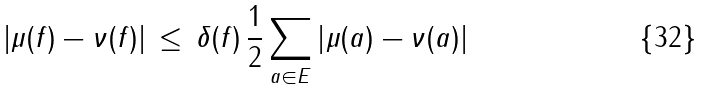<formula> <loc_0><loc_0><loc_500><loc_500>\left | \mu ( f ) - \nu ( f ) \right | \, \leq \, \delta ( f ) \, \frac { 1 } { 2 } \sum _ { a \in E } \left | \mu ( a ) - \nu ( a ) \right |</formula> 